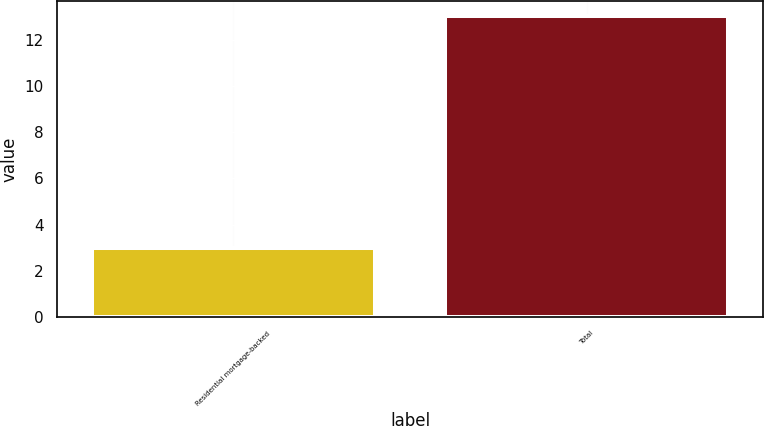Convert chart. <chart><loc_0><loc_0><loc_500><loc_500><bar_chart><fcel>Residential mortgage-backed<fcel>Total<nl><fcel>3<fcel>13<nl></chart> 